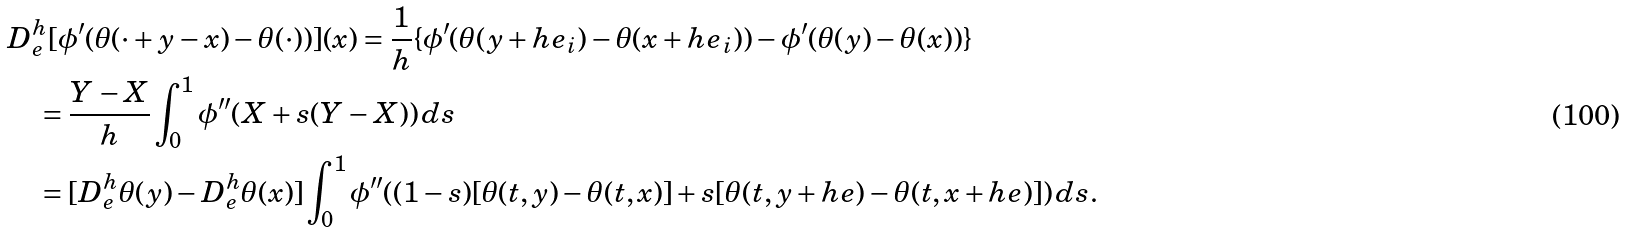Convert formula to latex. <formula><loc_0><loc_0><loc_500><loc_500>& D _ { e } ^ { h } [ \phi ^ { \prime } ( \theta ( \cdot + y - x ) - \theta ( \cdot ) ) ] ( x ) = \frac { 1 } { h } \{ \phi ^ { \prime } ( \theta ( y + h e _ { i } ) - \theta ( x + h e _ { i } ) ) - \phi ^ { \prime } ( \theta ( y ) - \theta ( x ) ) \} \\ & \quad = \frac { Y - X } { h } \int _ { 0 } ^ { 1 } \phi ^ { \prime \prime } ( X + s ( Y - X ) ) \, d s \\ & \quad = [ D _ { e } ^ { h } \theta ( y ) - D _ { e } ^ { h } \theta ( x ) ] \int _ { 0 } ^ { 1 } \phi ^ { \prime \prime } ( ( 1 - s ) [ \theta ( t , y ) - \theta ( t , x ) ] + s [ \theta ( t , y + h e ) - \theta ( t , x + h e ) ] ) \, d s .</formula> 